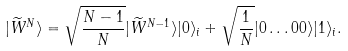Convert formula to latex. <formula><loc_0><loc_0><loc_500><loc_500>| \widetilde { W } ^ { N } \rangle = \sqrt { \frac { N - 1 } { N } } | \widetilde { W } ^ { N - 1 } \rangle | 0 \rangle _ { i } + \sqrt { \frac { 1 } { N } } | 0 \dots 0 0 \rangle | 1 \rangle _ { i } .</formula> 